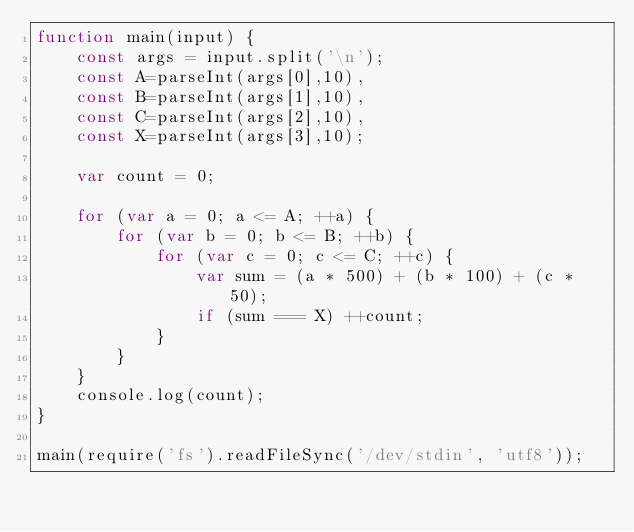<code> <loc_0><loc_0><loc_500><loc_500><_JavaScript_>function main(input) {
	const args = input.split('\n');
	const A=parseInt(args[0],10),
	const B=parseInt(args[1],10),
	const C=parseInt(args[2],10),
	const X=parseInt(args[3],10);

	var count = 0;

    for (var a = 0; a <= A; ++a) {
        for (var b = 0; b <= B; ++b) {
            for (var c = 0; c <= C; ++c) {
                var sum = (a * 500) + (b * 100) + (c * 50);
                if (sum === X) ++count;
            }
        }
    }
    console.log(count);
}
   
main(require('fs').readFileSync('/dev/stdin', 'utf8'));</code> 